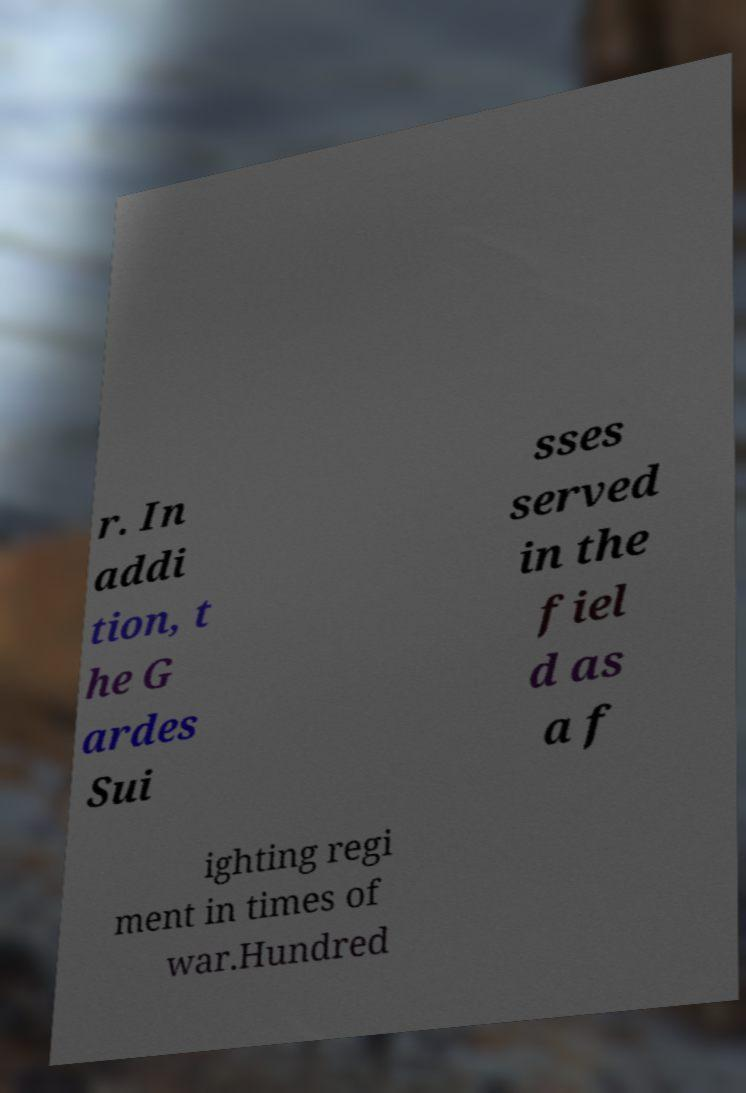Please identify and transcribe the text found in this image. r. In addi tion, t he G ardes Sui sses served in the fiel d as a f ighting regi ment in times of war.Hundred 